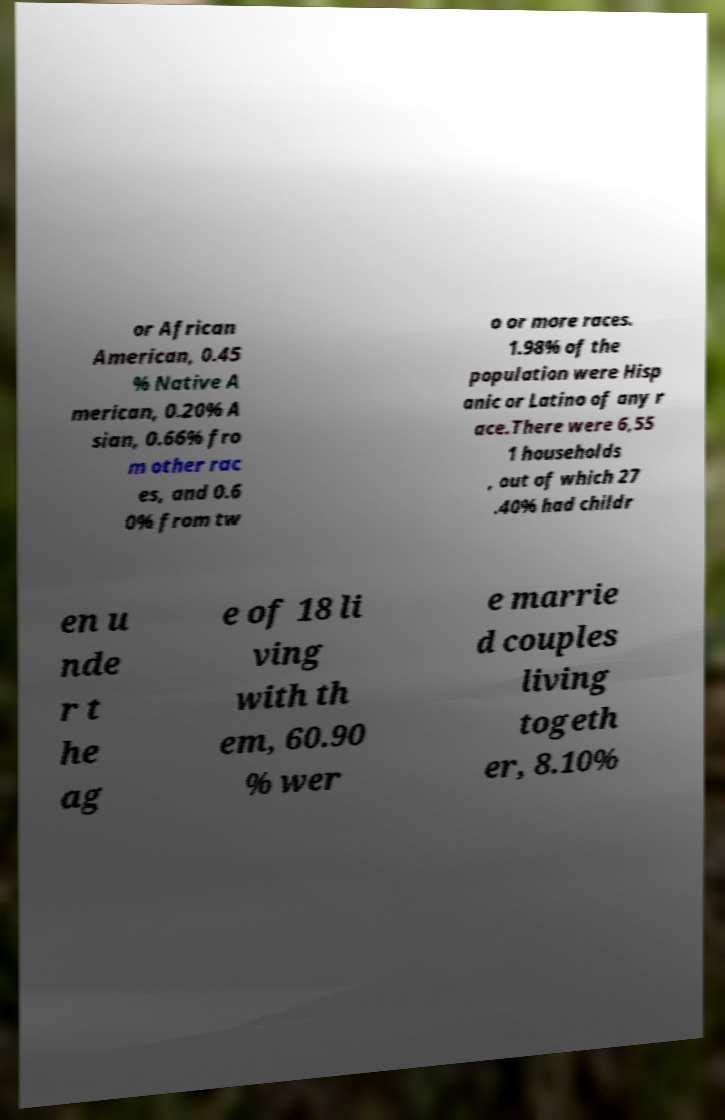Can you accurately transcribe the text from the provided image for me? or African American, 0.45 % Native A merican, 0.20% A sian, 0.66% fro m other rac es, and 0.6 0% from tw o or more races. 1.98% of the population were Hisp anic or Latino of any r ace.There were 6,55 1 households , out of which 27 .40% had childr en u nde r t he ag e of 18 li ving with th em, 60.90 % wer e marrie d couples living togeth er, 8.10% 